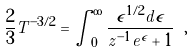<formula> <loc_0><loc_0><loc_500><loc_500>\frac { 2 } { 3 } \tilde { T } ^ { - 3 / 2 } = \int _ { 0 } ^ { \infty } \frac { \epsilon ^ { 1 / 2 } d \epsilon } { z ^ { - 1 } e ^ { \epsilon } + 1 } \ ,</formula> 